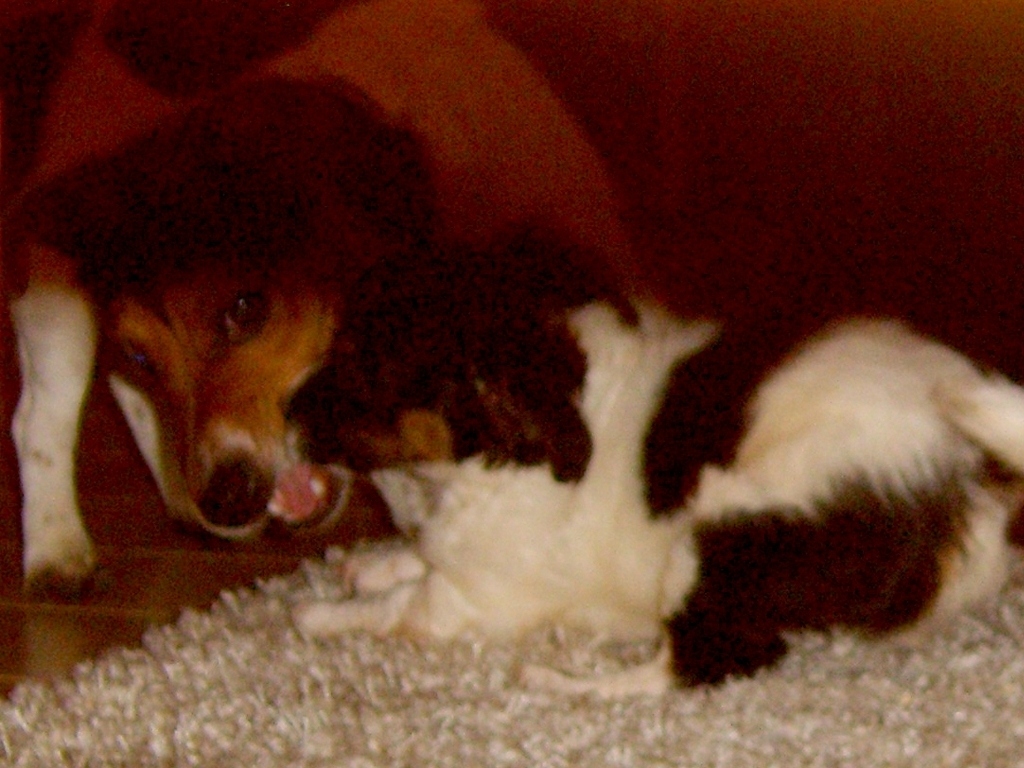Describe the setting of the image. The setting of the image is indoors, likely a home environment, indicated by the soft, carpeted area where the animals are situated. The background is dimly lit and features warm hues, suggesting a cozy and safe space for the pets. Can you tell what time of day it might be in the image? Given the dim lighting and warm tones in the background, it could be evening or night time, which is often when indoor lighting provides a soft glow, enhancing the feeling of warmth and comfort in the space. 